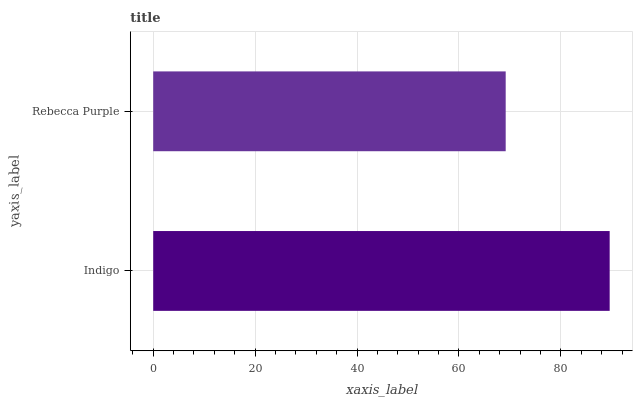Is Rebecca Purple the minimum?
Answer yes or no. Yes. Is Indigo the maximum?
Answer yes or no. Yes. Is Rebecca Purple the maximum?
Answer yes or no. No. Is Indigo greater than Rebecca Purple?
Answer yes or no. Yes. Is Rebecca Purple less than Indigo?
Answer yes or no. Yes. Is Rebecca Purple greater than Indigo?
Answer yes or no. No. Is Indigo less than Rebecca Purple?
Answer yes or no. No. Is Indigo the high median?
Answer yes or no. Yes. Is Rebecca Purple the low median?
Answer yes or no. Yes. Is Rebecca Purple the high median?
Answer yes or no. No. Is Indigo the low median?
Answer yes or no. No. 